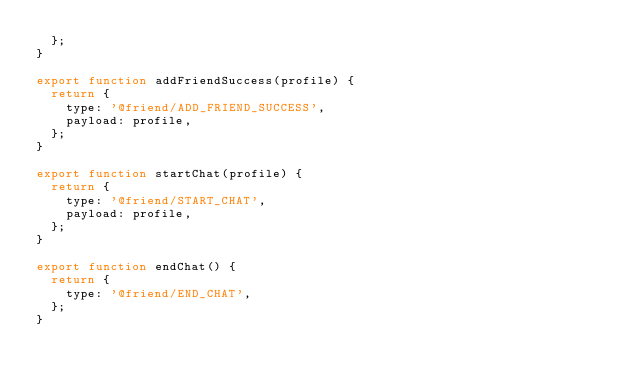<code> <loc_0><loc_0><loc_500><loc_500><_JavaScript_>  };
}

export function addFriendSuccess(profile) {
  return {
    type: '@friend/ADD_FRIEND_SUCCESS',
    payload: profile,
  };
}

export function startChat(profile) {
  return {
    type: '@friend/START_CHAT',
    payload: profile,
  };
}

export function endChat() {
  return {
    type: '@friend/END_CHAT',
  };
}
</code> 